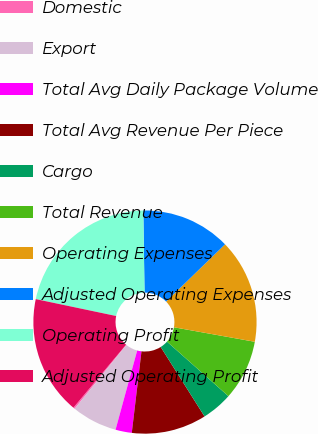Convert chart to OTSL. <chart><loc_0><loc_0><loc_500><loc_500><pie_chart><fcel>Domestic<fcel>Export<fcel>Total Avg Daily Package Volume<fcel>Total Avg Revenue Per Piece<fcel>Cargo<fcel>Total Revenue<fcel>Operating Expenses<fcel>Adjusted Operating Expenses<fcel>Operating Profit<fcel>Adjusted Operating Profit<nl><fcel>0.23%<fcel>6.6%<fcel>2.36%<fcel>10.85%<fcel>4.48%<fcel>8.73%<fcel>15.09%<fcel>12.97%<fcel>21.46%<fcel>17.22%<nl></chart> 